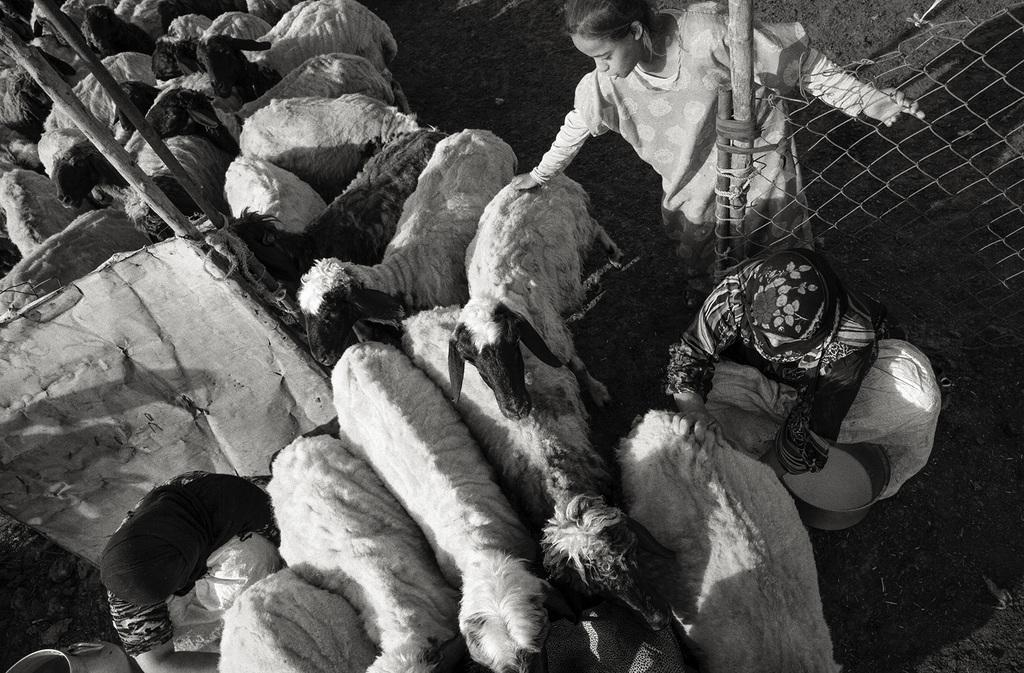What is the color scheme of the image? The image is black and white. What type of animals can be seen in the image? There are sheep in the image. Are there any human figures in the image? Yes, there are people in the image. What structures are present in the image? There are poles and a fence in the image. What other objects can be seen in the image? There are other objects in the image, but their specific details are not mentioned in the provided facts. Can you hear the creator of the image in the background? There is no mention of a creator in the image or the provided facts, and therefore it is not possible to hear them. How many clams are visible in the image? There are no clams present in the image. 